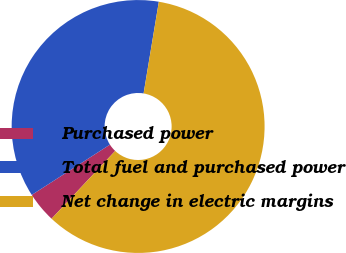Convert chart. <chart><loc_0><loc_0><loc_500><loc_500><pie_chart><fcel>Purchased power<fcel>Total fuel and purchased power<fcel>Net change in electric margins<nl><fcel>3.91%<fcel>36.72%<fcel>59.38%<nl></chart> 